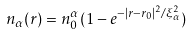Convert formula to latex. <formula><loc_0><loc_0><loc_500><loc_500>n _ { \alpha } ( { r } ) = n _ { 0 } ^ { \alpha } ( 1 - e ^ { - | { r } - { r } _ { 0 } | ^ { 2 } / \xi _ { \alpha } ^ { 2 } } )</formula> 